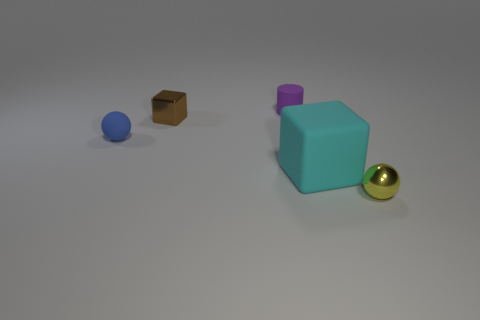What color is the tiny rubber object behind the small blue thing?
Provide a short and direct response. Purple. There is a tiny purple rubber object; does it have the same shape as the tiny metal object behind the big cyan object?
Provide a short and direct response. No. Are there any big matte blocks of the same color as the tiny cylinder?
Offer a very short reply. No. What size is the brown thing that is the same material as the yellow thing?
Your response must be concise. Small. Do the small cylinder and the shiny sphere have the same color?
Your response must be concise. No. There is a tiny object that is on the left side of the small brown metal block; is it the same shape as the yellow object?
Offer a terse response. Yes. What number of blue matte spheres have the same size as the cyan matte cube?
Offer a very short reply. 0. Are there any tiny yellow spheres that are on the left side of the block behind the cyan matte object?
Provide a short and direct response. No. How many objects are things that are in front of the tiny brown object or small yellow metal spheres?
Provide a short and direct response. 3. What number of blue metal things are there?
Provide a succinct answer. 0. 